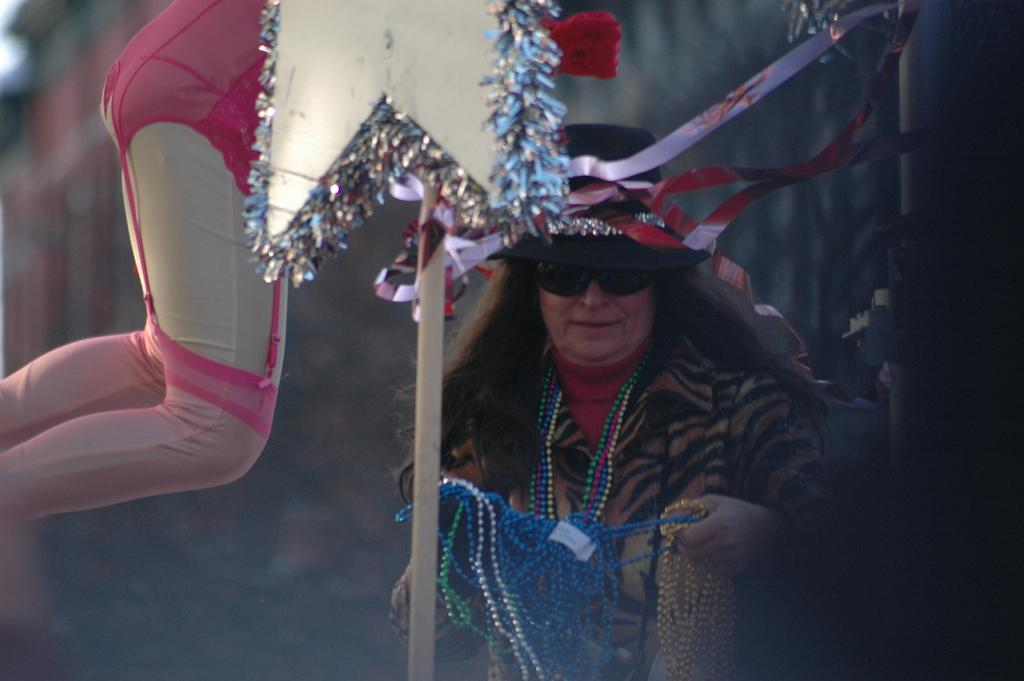Who is present in the image? There is a woman in the image. Can you describe any body parts visible in the image? Human legs are visible on the left side of the image. What type of bee can be seen flying near the woman's head in the image? There is no bee present in the image. How can the woman measure the distance between her legs in the image? The image does not show any tools or methods for measuring distances, so it cannot be determined how the woman might measure the distance between her legs. 